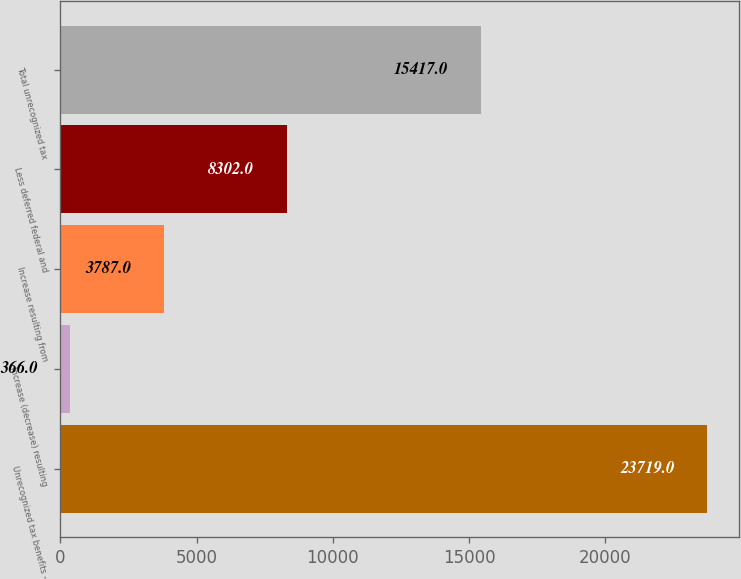Convert chart to OTSL. <chart><loc_0><loc_0><loc_500><loc_500><bar_chart><fcel>Unrecognized tax benefits -<fcel>Increase (decrease) resulting<fcel>Increase resulting from<fcel>Less deferred federal and<fcel>Total unrecognized tax<nl><fcel>23719<fcel>366<fcel>3787<fcel>8302<fcel>15417<nl></chart> 